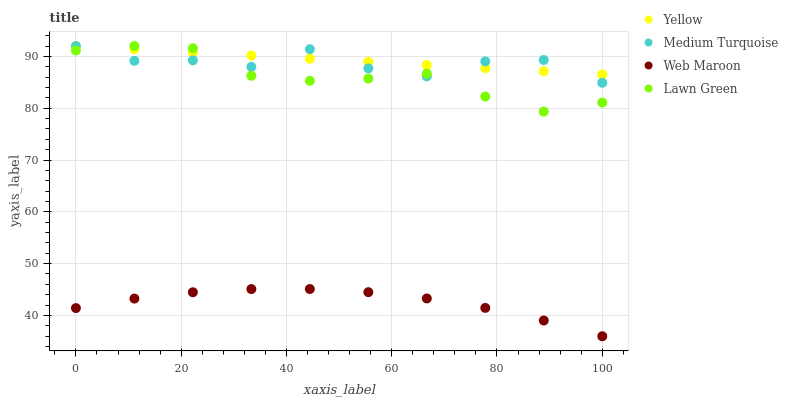Does Web Maroon have the minimum area under the curve?
Answer yes or no. Yes. Does Yellow have the maximum area under the curve?
Answer yes or no. Yes. Does Medium Turquoise have the minimum area under the curve?
Answer yes or no. No. Does Medium Turquoise have the maximum area under the curve?
Answer yes or no. No. Is Yellow the smoothest?
Answer yes or no. Yes. Is Medium Turquoise the roughest?
Answer yes or no. Yes. Is Web Maroon the smoothest?
Answer yes or no. No. Is Web Maroon the roughest?
Answer yes or no. No. Does Web Maroon have the lowest value?
Answer yes or no. Yes. Does Medium Turquoise have the lowest value?
Answer yes or no. No. Does Yellow have the highest value?
Answer yes or no. Yes. Does Web Maroon have the highest value?
Answer yes or no. No. Is Web Maroon less than Medium Turquoise?
Answer yes or no. Yes. Is Medium Turquoise greater than Web Maroon?
Answer yes or no. Yes. Does Lawn Green intersect Medium Turquoise?
Answer yes or no. Yes. Is Lawn Green less than Medium Turquoise?
Answer yes or no. No. Is Lawn Green greater than Medium Turquoise?
Answer yes or no. No. Does Web Maroon intersect Medium Turquoise?
Answer yes or no. No. 